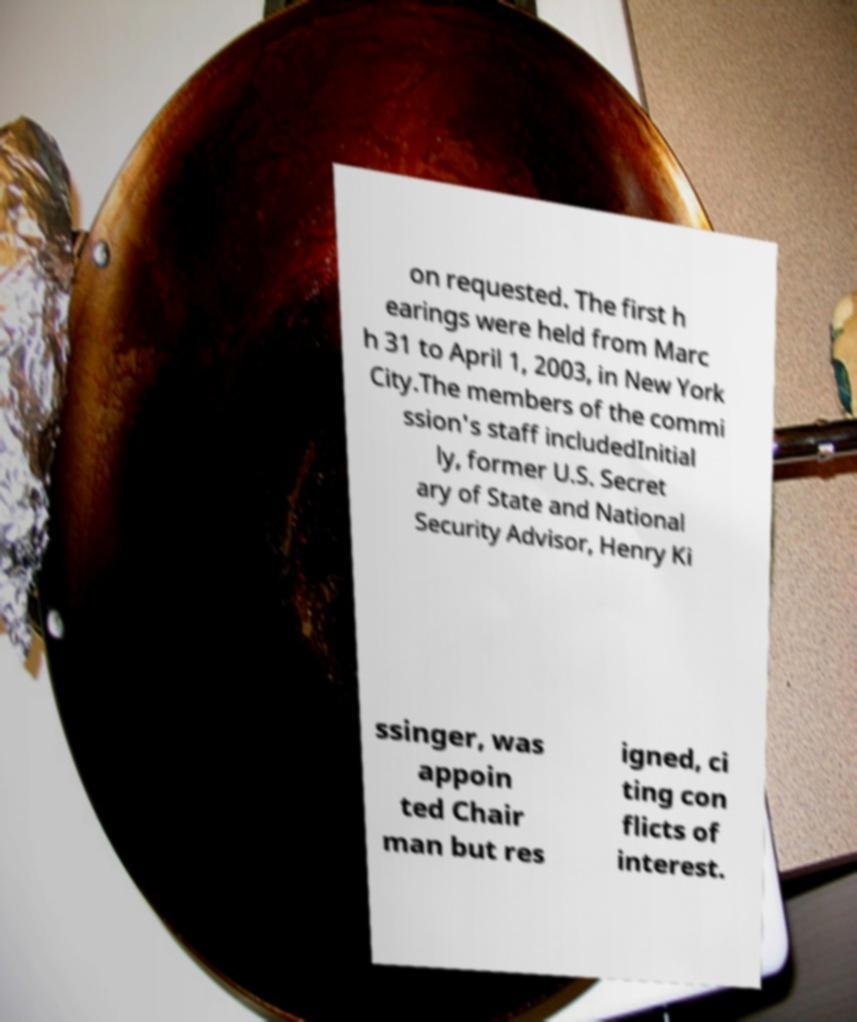For documentation purposes, I need the text within this image transcribed. Could you provide that? on requested. The first h earings were held from Marc h 31 to April 1, 2003, in New York City.The members of the commi ssion's staff includedInitial ly, former U.S. Secret ary of State and National Security Advisor, Henry Ki ssinger, was appoin ted Chair man but res igned, ci ting con flicts of interest. 